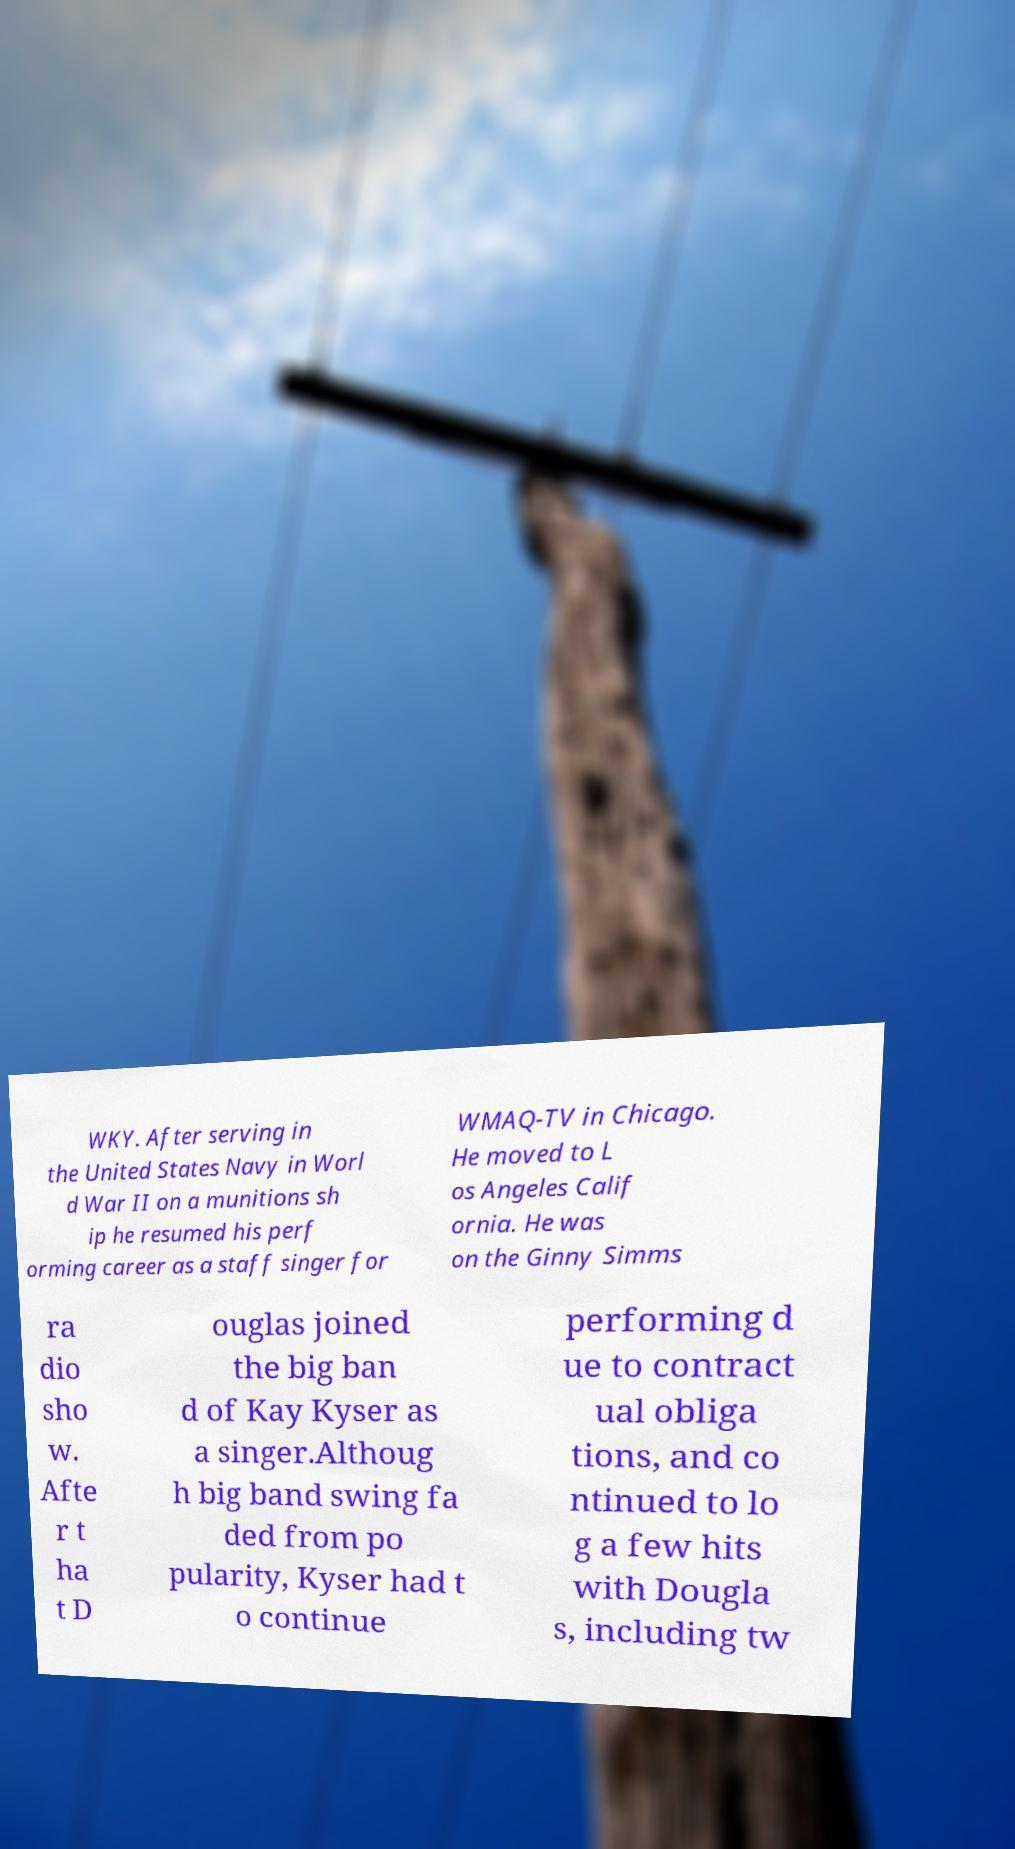There's text embedded in this image that I need extracted. Can you transcribe it verbatim? WKY. After serving in the United States Navy in Worl d War II on a munitions sh ip he resumed his perf orming career as a staff singer for WMAQ-TV in Chicago. He moved to L os Angeles Calif ornia. He was on the Ginny Simms ra dio sho w. Afte r t ha t D ouglas joined the big ban d of Kay Kyser as a singer.Althoug h big band swing fa ded from po pularity, Kyser had t o continue performing d ue to contract ual obliga tions, and co ntinued to lo g a few hits with Dougla s, including tw 